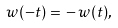Convert formula to latex. <formula><loc_0><loc_0><loc_500><loc_500>w ( - t ) = \, - \, w ( t ) ,</formula> 